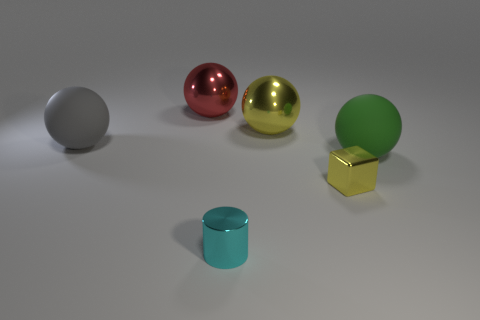Subtract all red balls. How many balls are left? 3 Subtract 2 spheres. How many spheres are left? 2 Subtract all gray spheres. How many spheres are left? 3 Subtract all spheres. How many objects are left? 2 Add 1 big red metallic objects. How many objects exist? 7 Add 1 big yellow shiny cylinders. How many big yellow shiny cylinders exist? 1 Subtract 1 yellow spheres. How many objects are left? 5 Subtract all yellow balls. Subtract all red cylinders. How many balls are left? 3 Subtract all metal balls. Subtract all big red shiny balls. How many objects are left? 3 Add 1 cyan metal objects. How many cyan metal objects are left? 2 